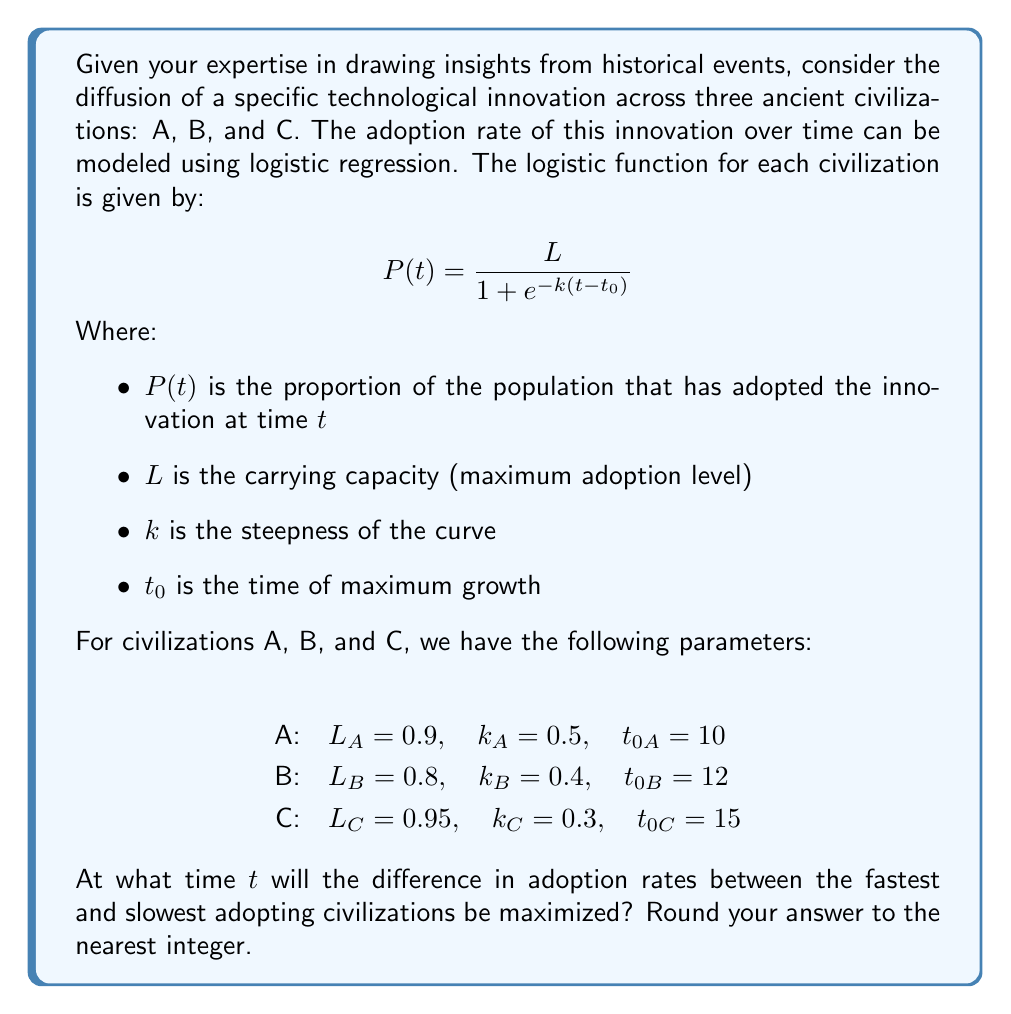Give your solution to this math problem. To solve this problem, we need to follow these steps:

1) First, we need to write out the logistic functions for each civilization:

   Civilization A: $$P_A(t) = \frac{0.9}{1 + e^{-0.5(t-10)}}$$
   Civilization B: $$P_B(t) = \frac{0.8}{1 + e^{-0.4(t-12)}}$$
   Civilization C: $$P_C(t) = \frac{0.95}{1 + e^{-0.3(t-15)}}$$

2) To find the time when the difference is maximized, we need to find the maximum of the difference function between the fastest and slowest adopting civilizations.

3) By observing the parameters, we can see that Civilization A will likely be the fastest (highest k and earliest t_0), and Civilization C will likely be the slowest (lowest k and latest t_0).

4) Let's define a new function D(t) as the difference between A and C:

   $$D(t) = P_A(t) - P_C(t) = \frac{0.9}{1 + e^{-0.5(t-10)}} - \frac{0.95}{1 + e^{-0.3(t-15)}}$$

5) To find the maximum of D(t), we need to find where its derivative equals zero. However, finding this analytically is complex due to the nature of the logistic function.

6) Instead, we can use a numerical approach. We can calculate D(t) for a range of t values and find where it reaches its maximum.

7) Let's calculate D(t) for t from 0 to 30 in steps of 1:

   t = 0:  D(0) = 0.0012
   t = 1:  D(1) = 0.0020
   ...
   t = 11: D(11) = 0.2805
   t = 12: D(12) = 0.2819
   t = 13: D(13) = 0.2756
   ...
   t = 30: D(30) = 0.0066

8) We can see that D(t) reaches its maximum at t = 12.

Therefore, the difference in adoption rates between the fastest and slowest adopting civilizations is maximized at t = 12.
Answer: 12 